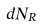<formula> <loc_0><loc_0><loc_500><loc_500>d N _ { R }</formula> 